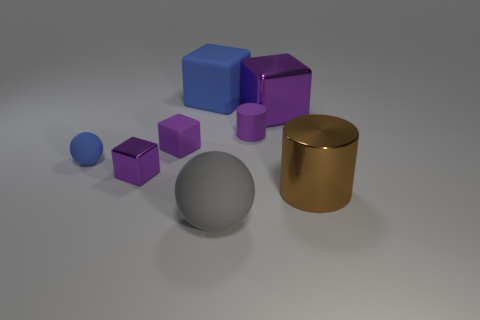The other matte object that is the same shape as the small blue matte thing is what color?
Your answer should be compact. Gray. How many things are the same color as the small matte cube?
Your answer should be compact. 3. What number of things are blue matte things that are on the right side of the tiny rubber ball or blue spheres?
Provide a short and direct response. 2. There is a metal object behind the purple cylinder; what size is it?
Make the answer very short. Large. Is the number of small purple rubber cylinders less than the number of rubber balls?
Your response must be concise. Yes. Is the material of the object that is in front of the metal cylinder the same as the purple thing that is left of the small rubber block?
Offer a terse response. No. There is a small rubber thing to the right of the large rubber object behind the brown thing in front of the tiny metallic object; what shape is it?
Your answer should be very brief. Cylinder. How many small things have the same material as the big purple block?
Make the answer very short. 1. There is a blue matte thing that is behind the purple cylinder; what number of tiny shiny blocks are on the left side of it?
Give a very brief answer. 1. There is a cylinder on the left side of the big brown thing; is it the same color as the metal block on the right side of the small purple metal thing?
Offer a very short reply. Yes. 